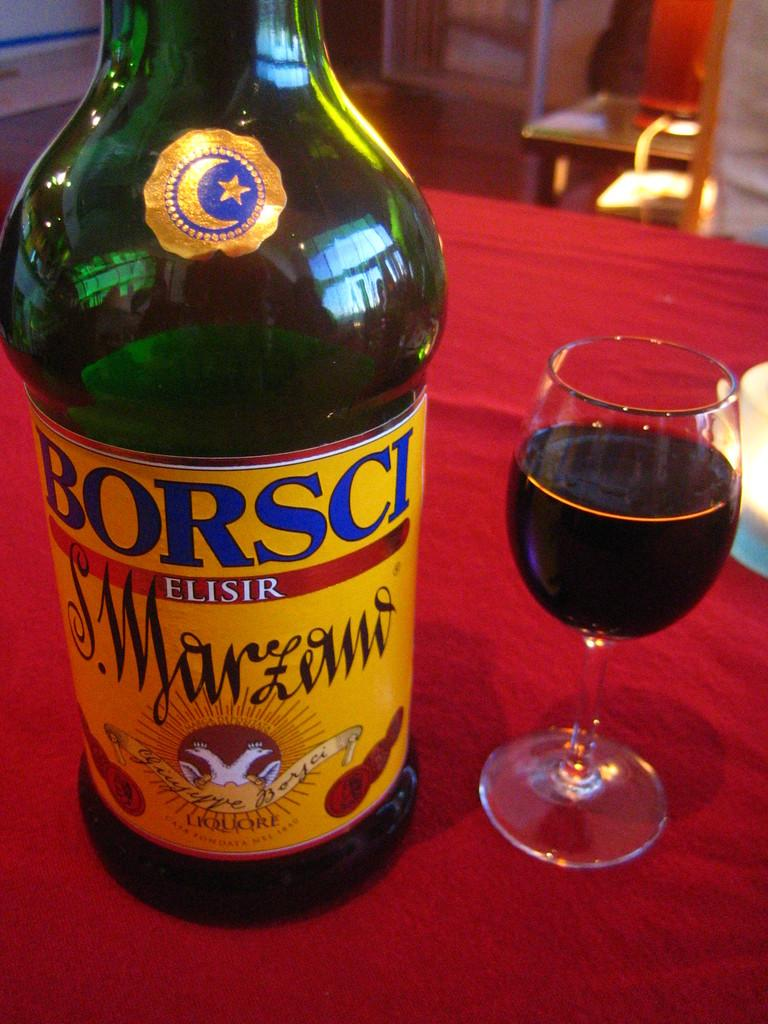<image>
Present a compact description of the photo's key features. A glass of wine next to a bottle of Borsci. 